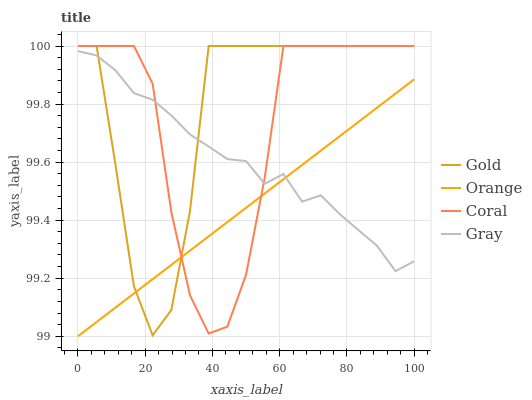Does Orange have the minimum area under the curve?
Answer yes or no. Yes. Does Gold have the maximum area under the curve?
Answer yes or no. Yes. Does Gray have the minimum area under the curve?
Answer yes or no. No. Does Gray have the maximum area under the curve?
Answer yes or no. No. Is Orange the smoothest?
Answer yes or no. Yes. Is Gold the roughest?
Answer yes or no. Yes. Is Gray the smoothest?
Answer yes or no. No. Is Gray the roughest?
Answer yes or no. No. Does Orange have the lowest value?
Answer yes or no. Yes. Does Coral have the lowest value?
Answer yes or no. No. Does Gold have the highest value?
Answer yes or no. Yes. Does Gray have the highest value?
Answer yes or no. No. Does Coral intersect Gold?
Answer yes or no. Yes. Is Coral less than Gold?
Answer yes or no. No. Is Coral greater than Gold?
Answer yes or no. No. 